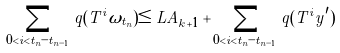<formula> <loc_0><loc_0><loc_500><loc_500>\sum _ { 0 < i < t _ { n } - t _ { n - 1 } } q ( T ^ { i } \omega _ { t _ { n } } ) \leq L A _ { k + 1 } + \sum _ { 0 < i < t _ { n } - t _ { n - 1 } } q ( T ^ { i } y ^ { \prime } )</formula> 